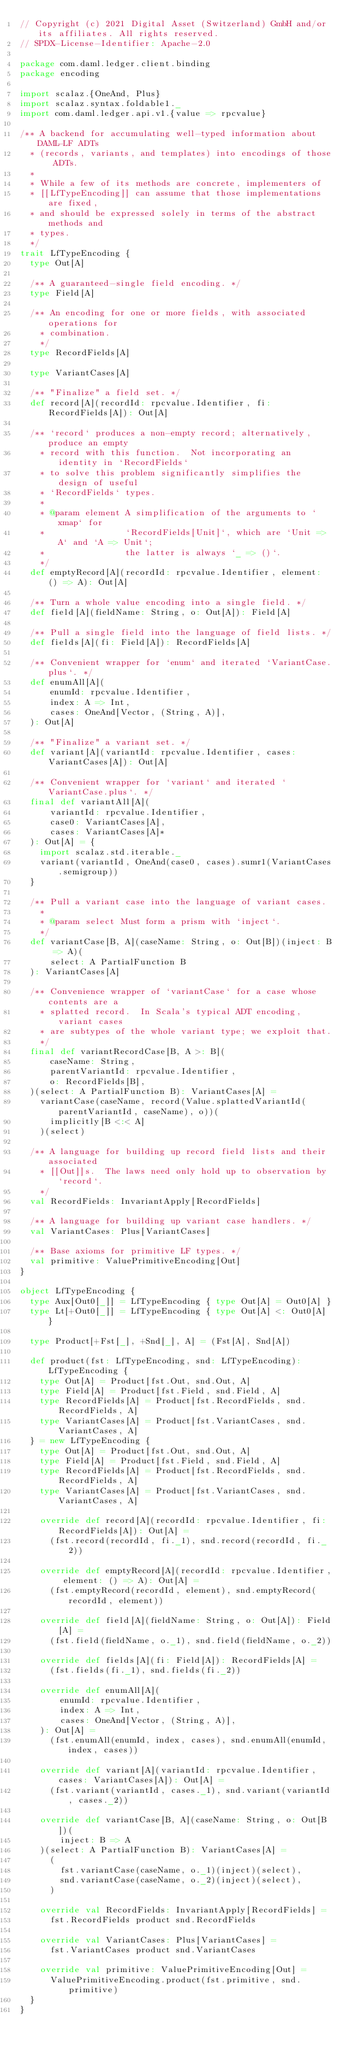<code> <loc_0><loc_0><loc_500><loc_500><_Scala_>// Copyright (c) 2021 Digital Asset (Switzerland) GmbH and/or its affiliates. All rights reserved.
// SPDX-License-Identifier: Apache-2.0

package com.daml.ledger.client.binding
package encoding

import scalaz.{OneAnd, Plus}
import scalaz.syntax.foldable1._
import com.daml.ledger.api.v1.{value => rpcvalue}

/** A backend for accumulating well-typed information about DAML-LF ADTs
  * (records, variants, and templates) into encodings of those ADTs.
  *
  * While a few of its methods are concrete, implementers of
  * [[LfTypeEncoding]] can assume that those implementations are fixed,
  * and should be expressed solely in terms of the abstract methods and
  * types.
  */
trait LfTypeEncoding {
  type Out[A]

  /** A guaranteed-single field encoding. */
  type Field[A]

  /** An encoding for one or more fields, with associated operations for
    * combination.
    */
  type RecordFields[A]

  type VariantCases[A]

  /** "Finalize" a field set. */
  def record[A](recordId: rpcvalue.Identifier, fi: RecordFields[A]): Out[A]

  /** `record` produces a non-empty record; alternatively, produce an empty
    * record with this function.  Not incorporating an identity in `RecordFields`
    * to solve this problem significantly simplifies the design of useful
    * `RecordFields` types.
    *
    * @param element A simplification of the arguments to `xmap` for
    *                `RecordFields[Unit]`, which are `Unit => A` and `A => Unit`;
    *                the latter is always `_ => ()`.
    */
  def emptyRecord[A](recordId: rpcvalue.Identifier, element: () => A): Out[A]

  /** Turn a whole value encoding into a single field. */
  def field[A](fieldName: String, o: Out[A]): Field[A]

  /** Pull a single field into the language of field lists. */
  def fields[A](fi: Field[A]): RecordFields[A]

  /** Convenient wrapper for `enum` and iterated `VariantCase.plus`. */
  def enumAll[A](
      enumId: rpcvalue.Identifier,
      index: A => Int,
      cases: OneAnd[Vector, (String, A)],
  ): Out[A]

  /** "Finalize" a variant set. */
  def variant[A](variantId: rpcvalue.Identifier, cases: VariantCases[A]): Out[A]

  /** Convenient wrapper for `variant` and iterated `VariantCase.plus`. */
  final def variantAll[A](
      variantId: rpcvalue.Identifier,
      case0: VariantCases[A],
      cases: VariantCases[A]*
  ): Out[A] = {
    import scalaz.std.iterable._
    variant(variantId, OneAnd(case0, cases).sumr1(VariantCases.semigroup))
  }

  /** Pull a variant case into the language of variant cases.
    *
    * @param select Must form a prism with `inject`.
    */
  def variantCase[B, A](caseName: String, o: Out[B])(inject: B => A)(
      select: A PartialFunction B
  ): VariantCases[A]

  /** Convenience wrapper of `variantCase` for a case whose contents are a
    * splatted record.  In Scala's typical ADT encoding, variant cases
    * are subtypes of the whole variant type; we exploit that.
    */
  final def variantRecordCase[B, A >: B](
      caseName: String,
      parentVariantId: rpcvalue.Identifier,
      o: RecordFields[B],
  )(select: A PartialFunction B): VariantCases[A] =
    variantCase(caseName, record(Value.splattedVariantId(parentVariantId, caseName), o))(
      implicitly[B <:< A]
    )(select)

  /** A language for building up record field lists and their associated
    * [[Out]]s.  The laws need only hold up to observation by `record`.
    */
  val RecordFields: InvariantApply[RecordFields]

  /** A language for building up variant case handlers. */
  val VariantCases: Plus[VariantCases]

  /** Base axioms for primitive LF types. */
  val primitive: ValuePrimitiveEncoding[Out]
}

object LfTypeEncoding {
  type Aux[Out0[_]] = LfTypeEncoding { type Out[A] = Out0[A] }
  type Lt[+Out0[_]] = LfTypeEncoding { type Out[A] <: Out0[A] }

  type Product[+Fst[_], +Snd[_], A] = (Fst[A], Snd[A])

  def product(fst: LfTypeEncoding, snd: LfTypeEncoding): LfTypeEncoding {
    type Out[A] = Product[fst.Out, snd.Out, A]
    type Field[A] = Product[fst.Field, snd.Field, A]
    type RecordFields[A] = Product[fst.RecordFields, snd.RecordFields, A]
    type VariantCases[A] = Product[fst.VariantCases, snd.VariantCases, A]
  } = new LfTypeEncoding {
    type Out[A] = Product[fst.Out, snd.Out, A]
    type Field[A] = Product[fst.Field, snd.Field, A]
    type RecordFields[A] = Product[fst.RecordFields, snd.RecordFields, A]
    type VariantCases[A] = Product[fst.VariantCases, snd.VariantCases, A]

    override def record[A](recordId: rpcvalue.Identifier, fi: RecordFields[A]): Out[A] =
      (fst.record(recordId, fi._1), snd.record(recordId, fi._2))

    override def emptyRecord[A](recordId: rpcvalue.Identifier, element: () => A): Out[A] =
      (fst.emptyRecord(recordId, element), snd.emptyRecord(recordId, element))

    override def field[A](fieldName: String, o: Out[A]): Field[A] =
      (fst.field(fieldName, o._1), snd.field(fieldName, o._2))

    override def fields[A](fi: Field[A]): RecordFields[A] =
      (fst.fields(fi._1), snd.fields(fi._2))

    override def enumAll[A](
        enumId: rpcvalue.Identifier,
        index: A => Int,
        cases: OneAnd[Vector, (String, A)],
    ): Out[A] =
      (fst.enumAll(enumId, index, cases), snd.enumAll(enumId, index, cases))

    override def variant[A](variantId: rpcvalue.Identifier, cases: VariantCases[A]): Out[A] =
      (fst.variant(variantId, cases._1), snd.variant(variantId, cases._2))

    override def variantCase[B, A](caseName: String, o: Out[B])(
        inject: B => A
    )(select: A PartialFunction B): VariantCases[A] =
      (
        fst.variantCase(caseName, o._1)(inject)(select),
        snd.variantCase(caseName, o._2)(inject)(select),
      )

    override val RecordFields: InvariantApply[RecordFields] =
      fst.RecordFields product snd.RecordFields

    override val VariantCases: Plus[VariantCases] =
      fst.VariantCases product snd.VariantCases

    override val primitive: ValuePrimitiveEncoding[Out] =
      ValuePrimitiveEncoding.product(fst.primitive, snd.primitive)
  }
}
</code> 